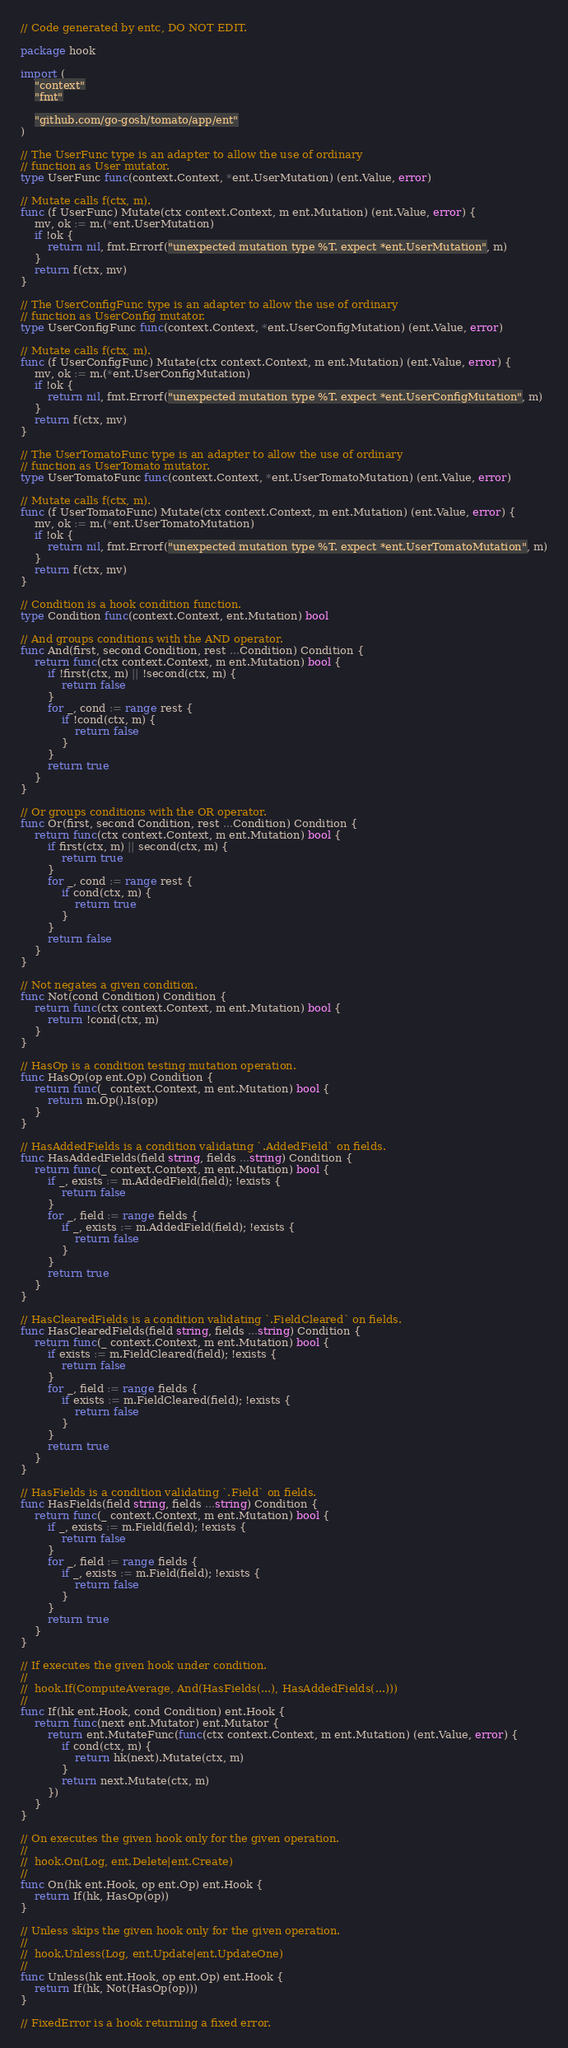Convert code to text. <code><loc_0><loc_0><loc_500><loc_500><_Go_>// Code generated by entc, DO NOT EDIT.

package hook

import (
	"context"
	"fmt"

	"github.com/go-gosh/tomato/app/ent"
)

// The UserFunc type is an adapter to allow the use of ordinary
// function as User mutator.
type UserFunc func(context.Context, *ent.UserMutation) (ent.Value, error)

// Mutate calls f(ctx, m).
func (f UserFunc) Mutate(ctx context.Context, m ent.Mutation) (ent.Value, error) {
	mv, ok := m.(*ent.UserMutation)
	if !ok {
		return nil, fmt.Errorf("unexpected mutation type %T. expect *ent.UserMutation", m)
	}
	return f(ctx, mv)
}

// The UserConfigFunc type is an adapter to allow the use of ordinary
// function as UserConfig mutator.
type UserConfigFunc func(context.Context, *ent.UserConfigMutation) (ent.Value, error)

// Mutate calls f(ctx, m).
func (f UserConfigFunc) Mutate(ctx context.Context, m ent.Mutation) (ent.Value, error) {
	mv, ok := m.(*ent.UserConfigMutation)
	if !ok {
		return nil, fmt.Errorf("unexpected mutation type %T. expect *ent.UserConfigMutation", m)
	}
	return f(ctx, mv)
}

// The UserTomatoFunc type is an adapter to allow the use of ordinary
// function as UserTomato mutator.
type UserTomatoFunc func(context.Context, *ent.UserTomatoMutation) (ent.Value, error)

// Mutate calls f(ctx, m).
func (f UserTomatoFunc) Mutate(ctx context.Context, m ent.Mutation) (ent.Value, error) {
	mv, ok := m.(*ent.UserTomatoMutation)
	if !ok {
		return nil, fmt.Errorf("unexpected mutation type %T. expect *ent.UserTomatoMutation", m)
	}
	return f(ctx, mv)
}

// Condition is a hook condition function.
type Condition func(context.Context, ent.Mutation) bool

// And groups conditions with the AND operator.
func And(first, second Condition, rest ...Condition) Condition {
	return func(ctx context.Context, m ent.Mutation) bool {
		if !first(ctx, m) || !second(ctx, m) {
			return false
		}
		for _, cond := range rest {
			if !cond(ctx, m) {
				return false
			}
		}
		return true
	}
}

// Or groups conditions with the OR operator.
func Or(first, second Condition, rest ...Condition) Condition {
	return func(ctx context.Context, m ent.Mutation) bool {
		if first(ctx, m) || second(ctx, m) {
			return true
		}
		for _, cond := range rest {
			if cond(ctx, m) {
				return true
			}
		}
		return false
	}
}

// Not negates a given condition.
func Not(cond Condition) Condition {
	return func(ctx context.Context, m ent.Mutation) bool {
		return !cond(ctx, m)
	}
}

// HasOp is a condition testing mutation operation.
func HasOp(op ent.Op) Condition {
	return func(_ context.Context, m ent.Mutation) bool {
		return m.Op().Is(op)
	}
}

// HasAddedFields is a condition validating `.AddedField` on fields.
func HasAddedFields(field string, fields ...string) Condition {
	return func(_ context.Context, m ent.Mutation) bool {
		if _, exists := m.AddedField(field); !exists {
			return false
		}
		for _, field := range fields {
			if _, exists := m.AddedField(field); !exists {
				return false
			}
		}
		return true
	}
}

// HasClearedFields is a condition validating `.FieldCleared` on fields.
func HasClearedFields(field string, fields ...string) Condition {
	return func(_ context.Context, m ent.Mutation) bool {
		if exists := m.FieldCleared(field); !exists {
			return false
		}
		for _, field := range fields {
			if exists := m.FieldCleared(field); !exists {
				return false
			}
		}
		return true
	}
}

// HasFields is a condition validating `.Field` on fields.
func HasFields(field string, fields ...string) Condition {
	return func(_ context.Context, m ent.Mutation) bool {
		if _, exists := m.Field(field); !exists {
			return false
		}
		for _, field := range fields {
			if _, exists := m.Field(field); !exists {
				return false
			}
		}
		return true
	}
}

// If executes the given hook under condition.
//
//	hook.If(ComputeAverage, And(HasFields(...), HasAddedFields(...)))
//
func If(hk ent.Hook, cond Condition) ent.Hook {
	return func(next ent.Mutator) ent.Mutator {
		return ent.MutateFunc(func(ctx context.Context, m ent.Mutation) (ent.Value, error) {
			if cond(ctx, m) {
				return hk(next).Mutate(ctx, m)
			}
			return next.Mutate(ctx, m)
		})
	}
}

// On executes the given hook only for the given operation.
//
//	hook.On(Log, ent.Delete|ent.Create)
//
func On(hk ent.Hook, op ent.Op) ent.Hook {
	return If(hk, HasOp(op))
}

// Unless skips the given hook only for the given operation.
//
//	hook.Unless(Log, ent.Update|ent.UpdateOne)
//
func Unless(hk ent.Hook, op ent.Op) ent.Hook {
	return If(hk, Not(HasOp(op)))
}

// FixedError is a hook returning a fixed error.</code> 